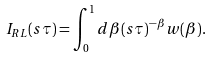Convert formula to latex. <formula><loc_0><loc_0><loc_500><loc_500>I _ { R L } ( s \tau ) = \int _ { 0 } ^ { 1 } d \beta ( s \tau ) ^ { - \beta } w ( \beta ) .</formula> 